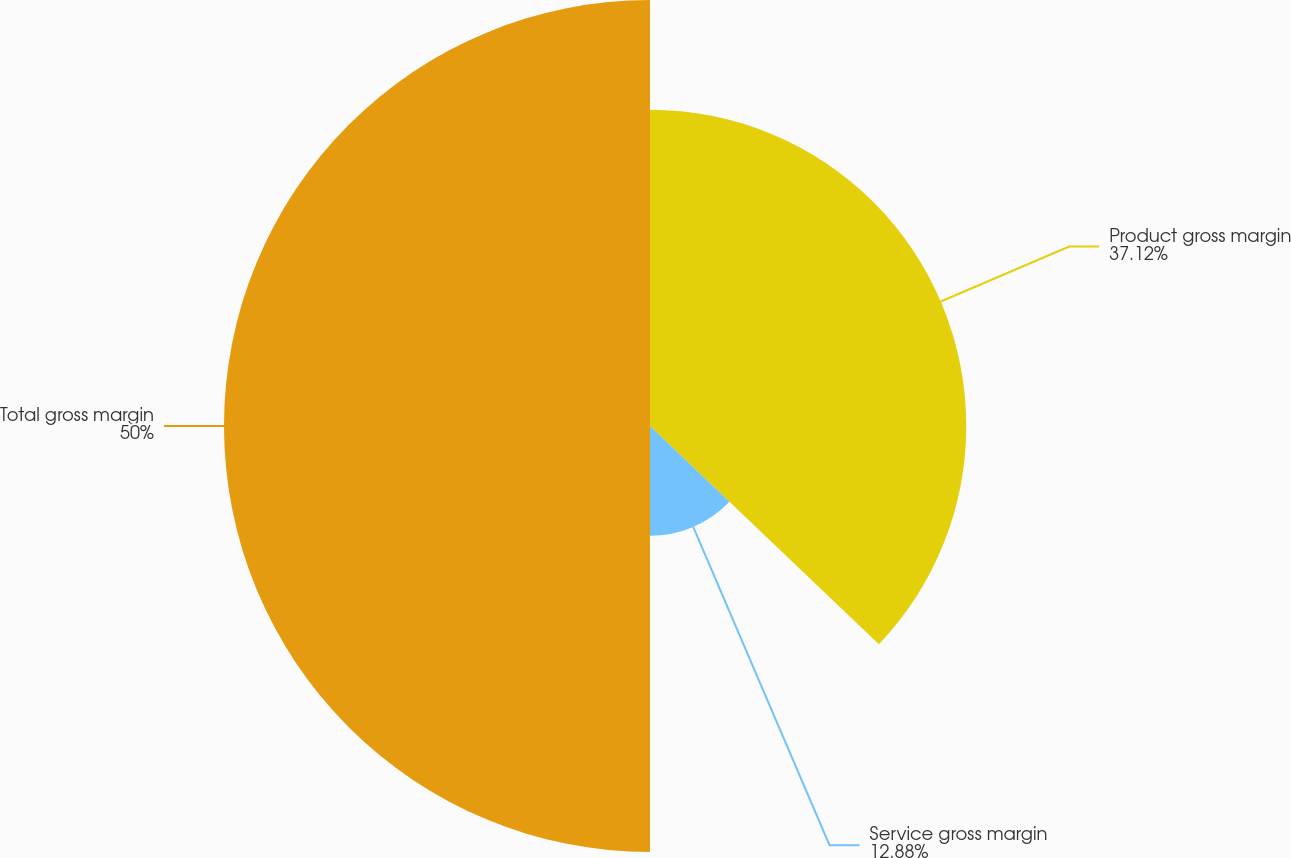<chart> <loc_0><loc_0><loc_500><loc_500><pie_chart><fcel>Product gross margin<fcel>Service gross margin<fcel>Total gross margin<nl><fcel>37.12%<fcel>12.88%<fcel>50.0%<nl></chart> 